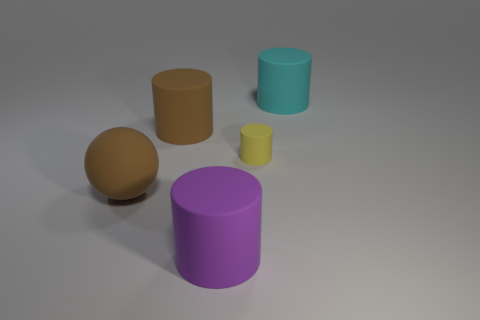Subtract all small yellow rubber cylinders. How many cylinders are left? 3 Add 1 small yellow things. How many objects exist? 6 Subtract 1 spheres. How many spheres are left? 0 Subtract all yellow cylinders. How many cylinders are left? 3 Subtract all cylinders. How many objects are left? 1 Add 1 brown objects. How many brown objects exist? 3 Subtract 0 gray cylinders. How many objects are left? 5 Subtract all brown cylinders. Subtract all yellow blocks. How many cylinders are left? 3 Subtract all small purple metallic balls. Subtract all brown objects. How many objects are left? 3 Add 5 large things. How many large things are left? 9 